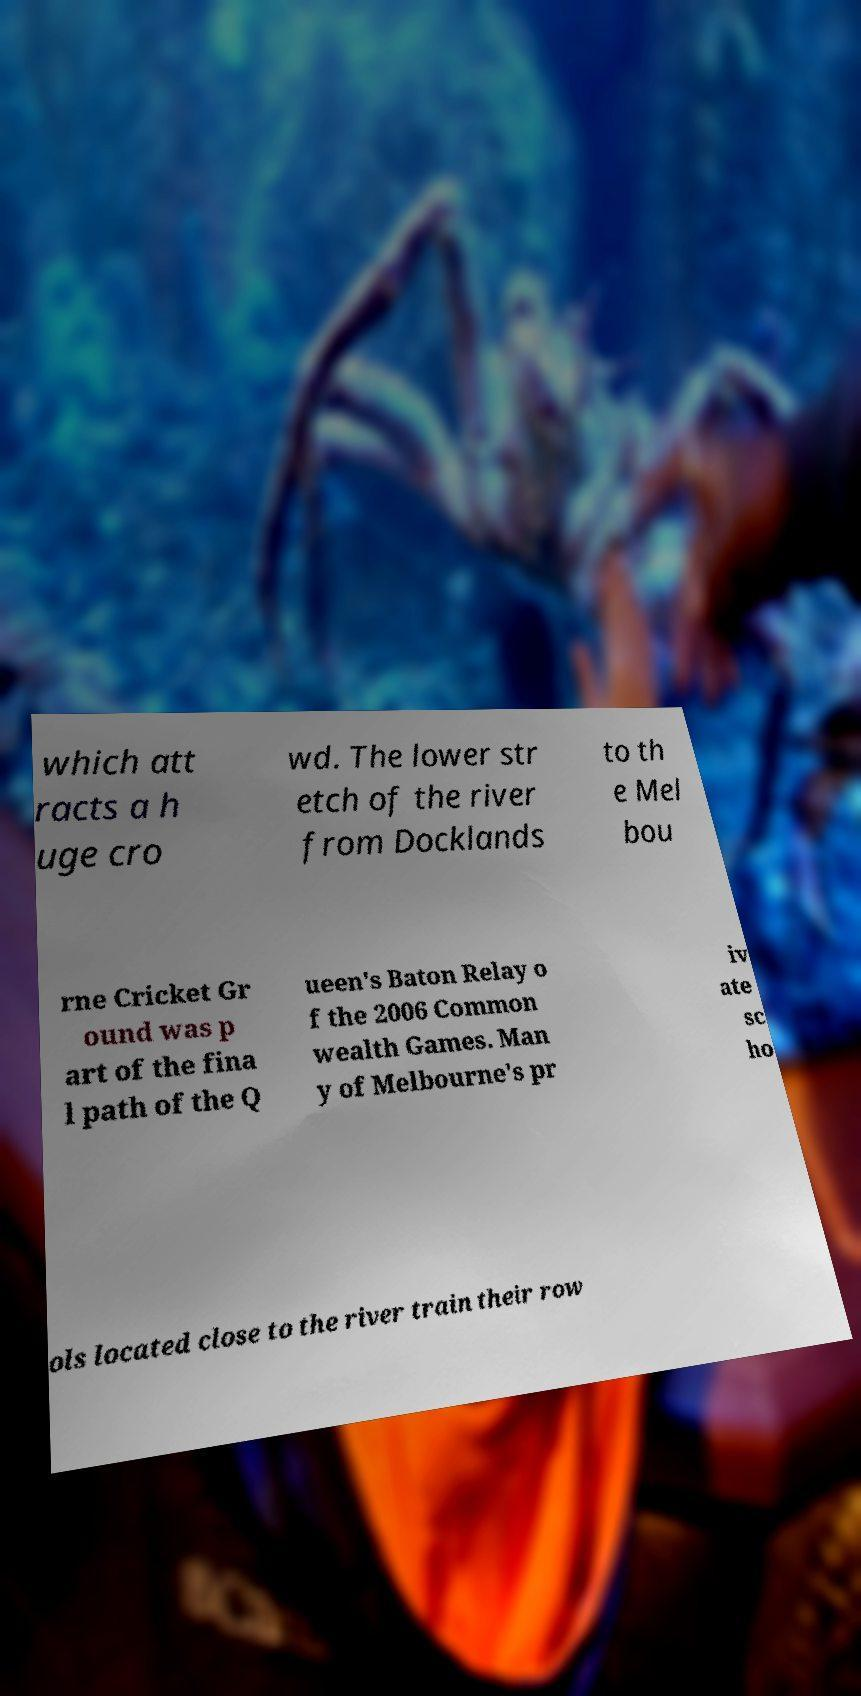Please read and relay the text visible in this image. What does it say? which att racts a h uge cro wd. The lower str etch of the river from Docklands to th e Mel bou rne Cricket Gr ound was p art of the fina l path of the Q ueen's Baton Relay o f the 2006 Common wealth Games. Man y of Melbourne's pr iv ate sc ho ols located close to the river train their row 